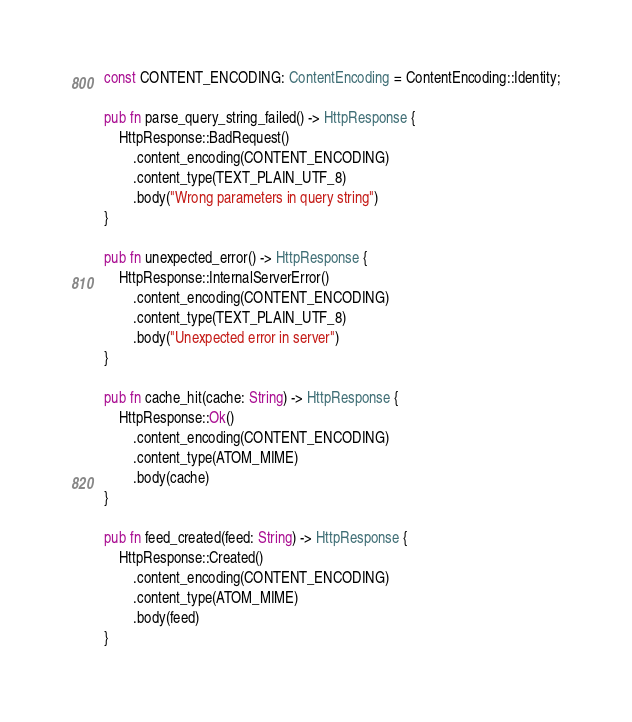<code> <loc_0><loc_0><loc_500><loc_500><_Rust_>const CONTENT_ENCODING: ContentEncoding = ContentEncoding::Identity;

pub fn parse_query_string_failed() -> HttpResponse {
    HttpResponse::BadRequest()
        .content_encoding(CONTENT_ENCODING)
        .content_type(TEXT_PLAIN_UTF_8)
        .body("Wrong parameters in query string")
}

pub fn unexpected_error() -> HttpResponse {
    HttpResponse::InternalServerError()
        .content_encoding(CONTENT_ENCODING)
        .content_type(TEXT_PLAIN_UTF_8)
        .body("Unexpected error in server")
}

pub fn cache_hit(cache: String) -> HttpResponse {
    HttpResponse::Ok()
        .content_encoding(CONTENT_ENCODING)
        .content_type(ATOM_MIME)
        .body(cache)
}

pub fn feed_created(feed: String) -> HttpResponse {
    HttpResponse::Created()
        .content_encoding(CONTENT_ENCODING)
        .content_type(ATOM_MIME)
        .body(feed)
}
</code> 